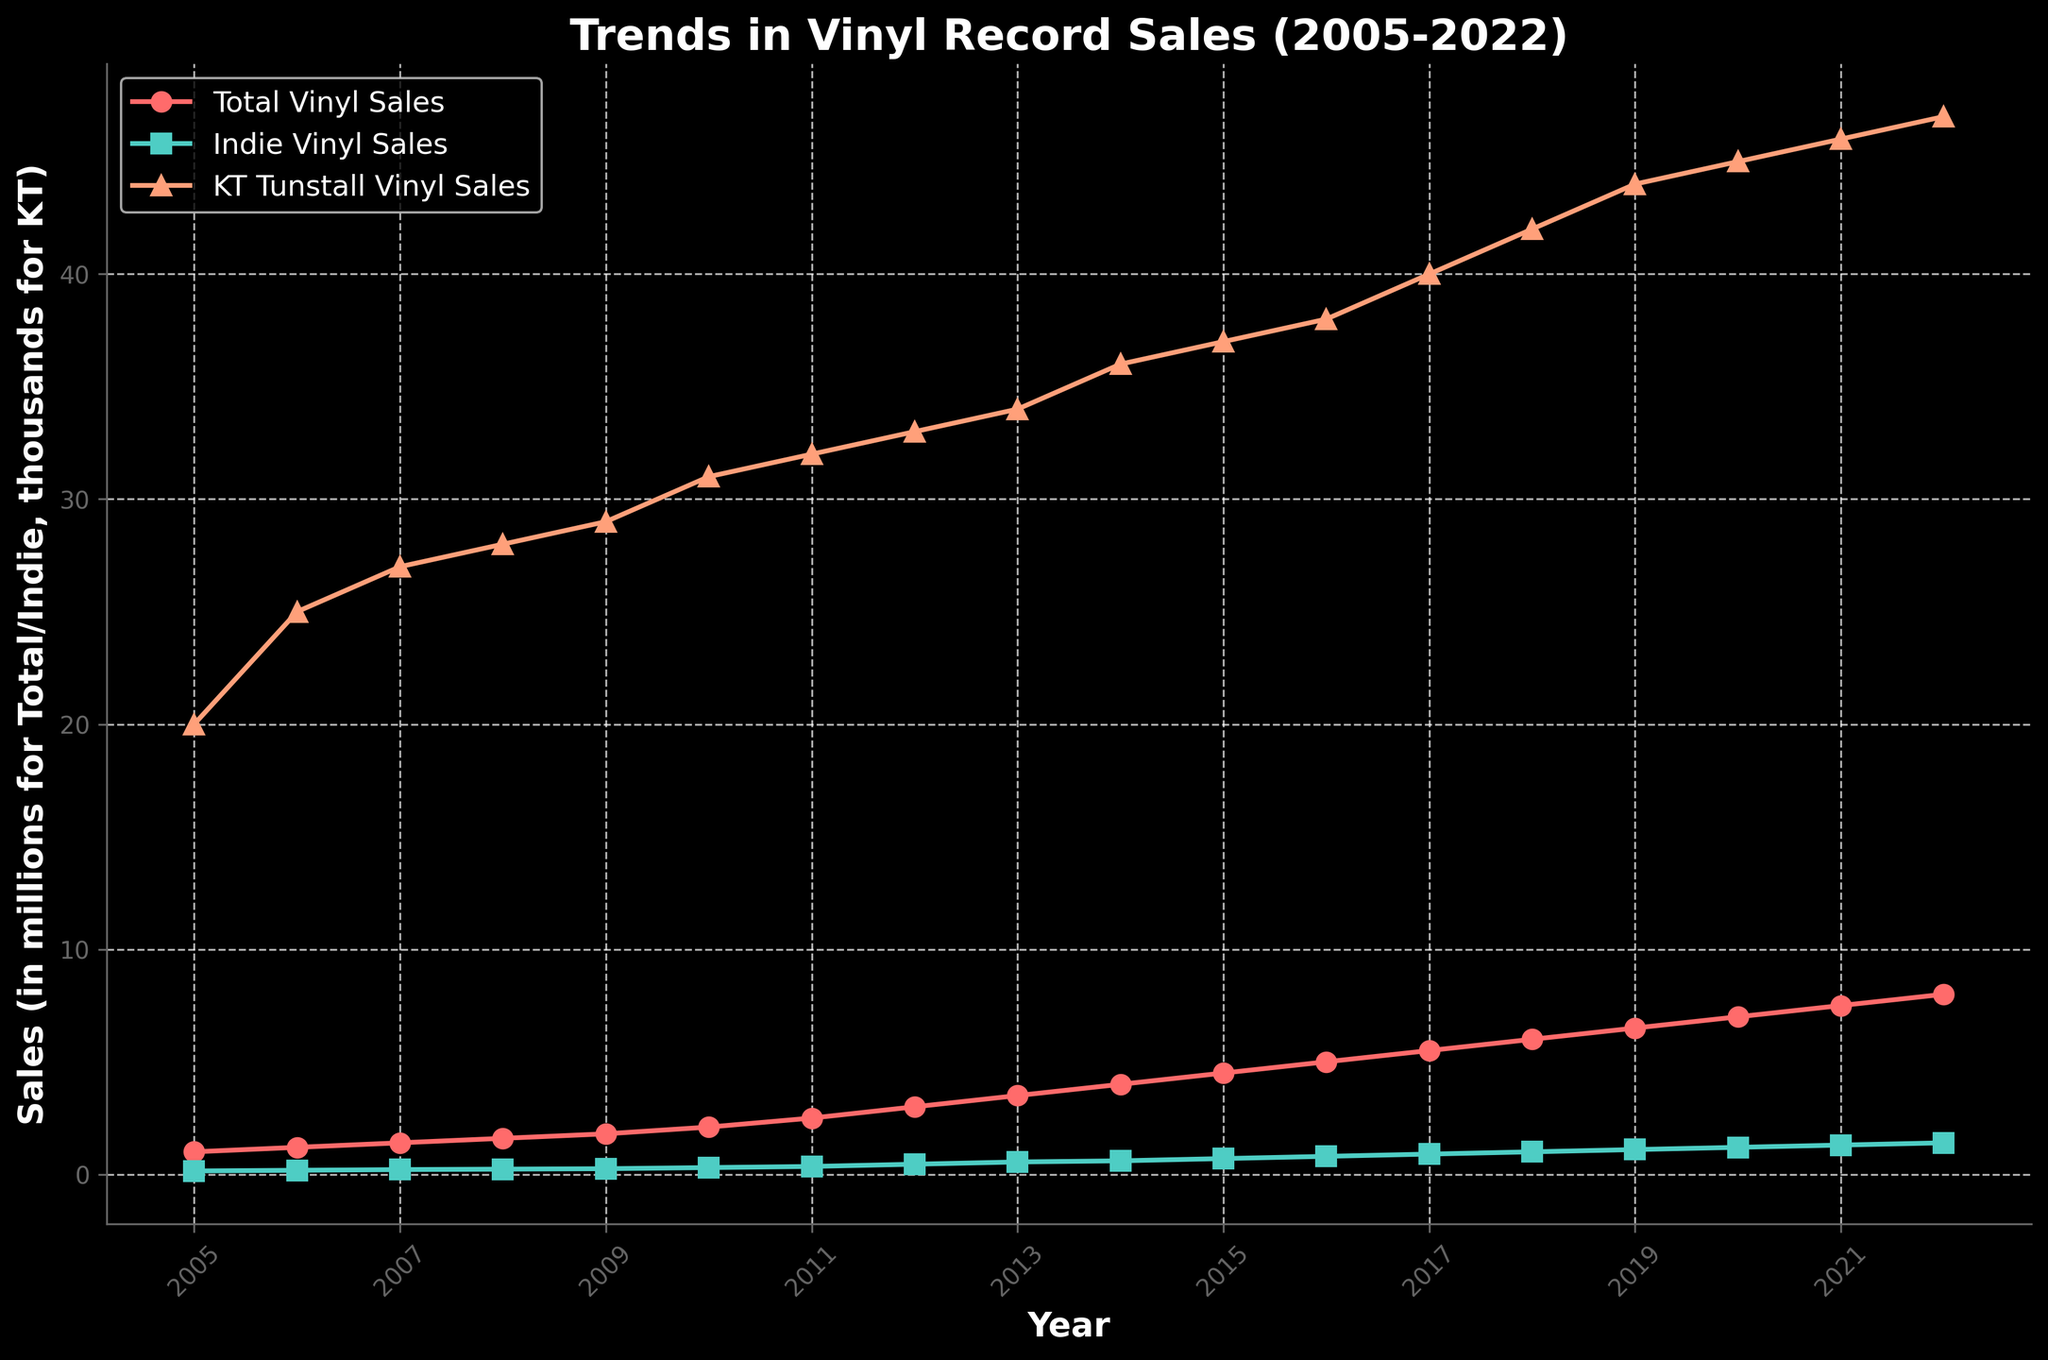What is the title of the plot? The title is usually located at the top of the plot. In the provided plot, the title is "Trends in Vinyl Record Sales (2005-2022)".
Answer: Trends in Vinyl Record Sales (2005-2022) What do the different colored lines represent in the plot? The figure legend typically illustrates what each color represents. In this plot, the red line represents Total Vinyl Sales, the teal line represents Indie Vinyl Sales, and the orange line represents KT Tunstall Vinyl Sales.
Answer: Total Vinyl Sales, Indie Vinyl Sales, KT Tunstall Vinyl Sales What year shows the highest total vinyl sales? To find the year with the highest total vinyl sales, look for the highest point on the red line in the plot. The highest point in the red line corresponds to the year 2022.
Answer: 2022 How much did KT Tunstall's vinyl sales increase from 2005 to 2022? To determine the increase, subtract the sales of KT Tunstall Vinyl in 2005 from the sales in 2022. From the plot, KT Tunstall Vinyl Sales in 2005 were 20,000 and in 2022 were 47,000. The increase is 47,000 - 20,000 = 27,000.
Answer: 27,000 In what year did indie vinyl sales reach 1 million? To find the year when the teal line (indie vinyl sales) first reaches 1 million, you observe the graph. It occurred in 2018.
Answer: 2018 Compare the trend of total vinyl sales and indie vinyl sales over the years. Which one grew faster? By comparing the slopes of the red and teal lines, you can determine the growth rate. Both slopes increase over time, but indie vinyl sales (teal line) appear to accelerate more rapidly than total vinyl sales (red line), especially after 2010.
Answer: Indie Vinyl Sales In which year did KT Tunstall's vinyl sales surpass 40,000 units? From the orange line on the plot, KT Tunstall’s sales first exceeded 40,000 units in 2017.
Answer: 2017 What is the average total vinyl sales from 2005 to 2022? To find the average, sum the total vinyl sales for each year from 2005 to 2022 and divide by the number of years. (1+1.2+1.4+1.6+1.8+2.1+2.5+3+3.5+4+4.5+5+5.5+6+6.5+7+7.5+8)/18 = 4.133 million units
Answer: 4.133 million How did the total vinyl sales compare between 2010 and 2020? To compare, look at the values on the red line for 2010 and 2020. Total vinyl sales in 2010 were 2.1 million, and in 2020, they were 7 million. The sales increased by 7 - 2.1 = 4.9 million.
Answer: Increased by 4.9 million What percentage of total vinyl sales were indie vinyl sales in 2022? To find the percentage, divide the indie vinyl sales by the total vinyl sales for 2022, and multiply by 100. (1.4/8) * 100 = 17.5%
Answer: 17.5% 